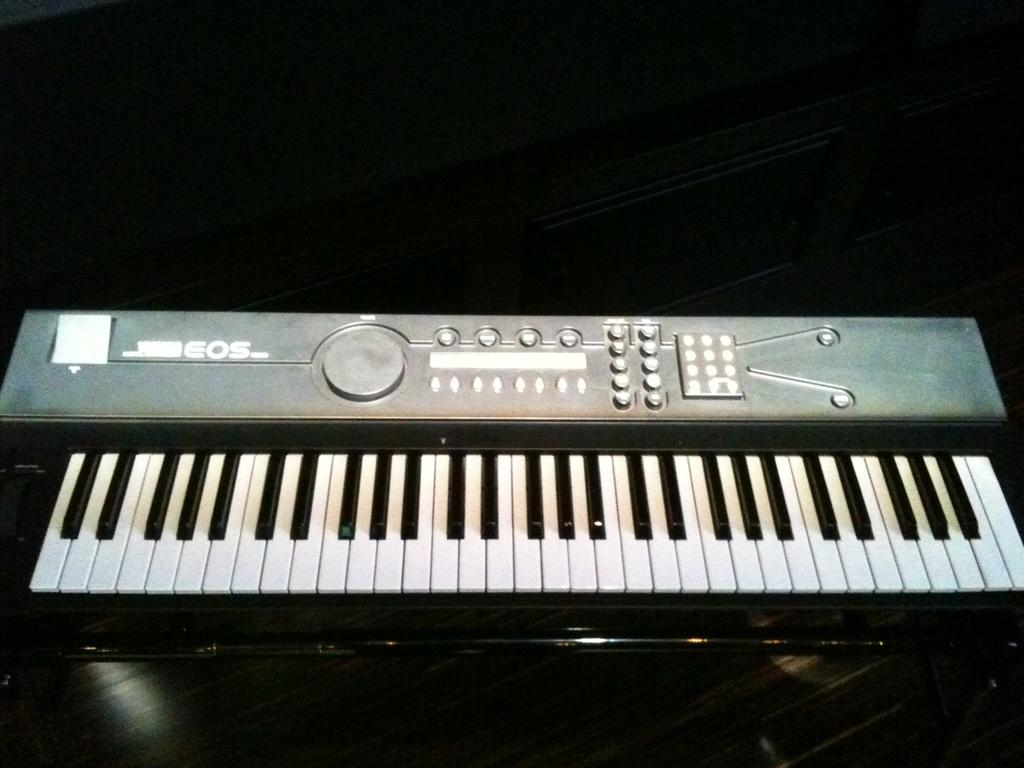What is the main subject in the center of the image? There is a piano in the center of the image. What type of crayon is the piano made of in the image? The piano is not made of crayons; it is a musical instrument made of materials such as wood and metal. 